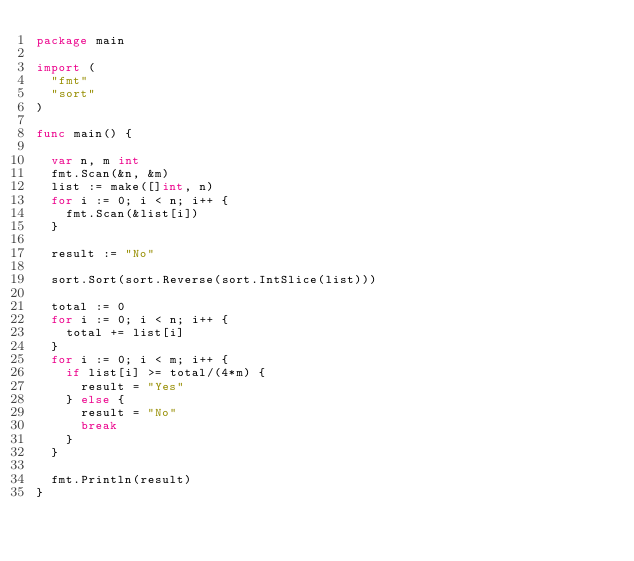<code> <loc_0><loc_0><loc_500><loc_500><_Go_>package main

import (
	"fmt"
	"sort"
)

func main() {

	var n, m int
	fmt.Scan(&n, &m)
	list := make([]int, n)
	for i := 0; i < n; i++ {
		fmt.Scan(&list[i])
	}

	result := "No"

	sort.Sort(sort.Reverse(sort.IntSlice(list)))

	total := 0
	for i := 0; i < n; i++ {
		total += list[i]
	}
	for i := 0; i < m; i++ {
		if list[i] >= total/(4*m) {
			result = "Yes"
		} else {
			result = "No"
			break
		}
	}

	fmt.Println(result)
}
</code> 